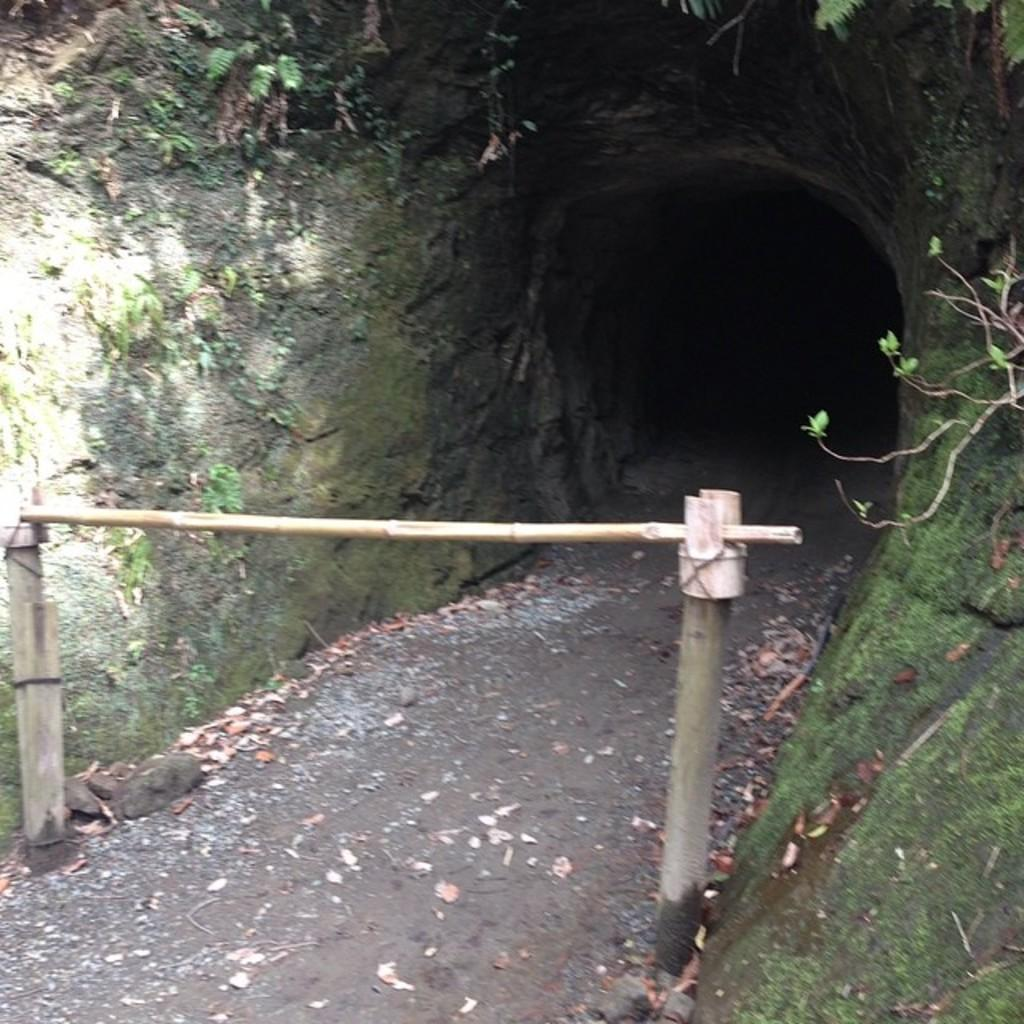What object is placed on two poles in the image? There is a wooden stick placed on two poles in the image. What else can be seen in the image besides the wooden stick? There are plants and a cave in the image. What type of rhythm is being played by the plants in the image? There is no indication of any rhythm being played in the image, as plants do not produce music or rhythm. 